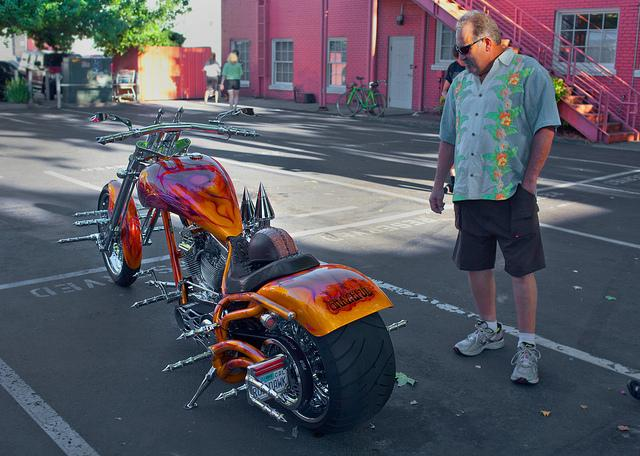How was this type of bike made? custom 